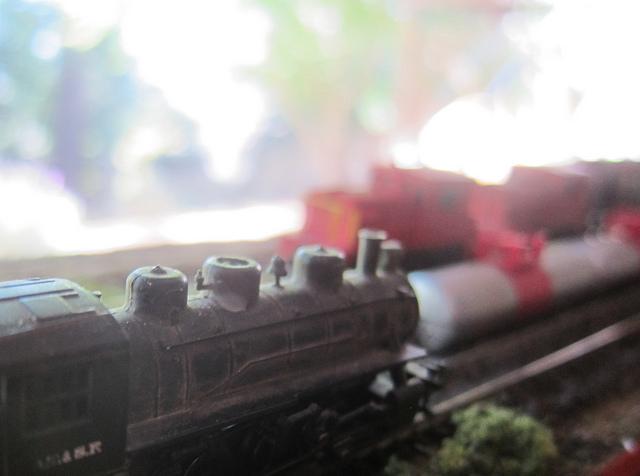How many cars are in the picture?
Give a very brief answer. 3. Is this a working model?
Write a very short answer. Yes. Is the train on real tracks?
Short answer required. No. 